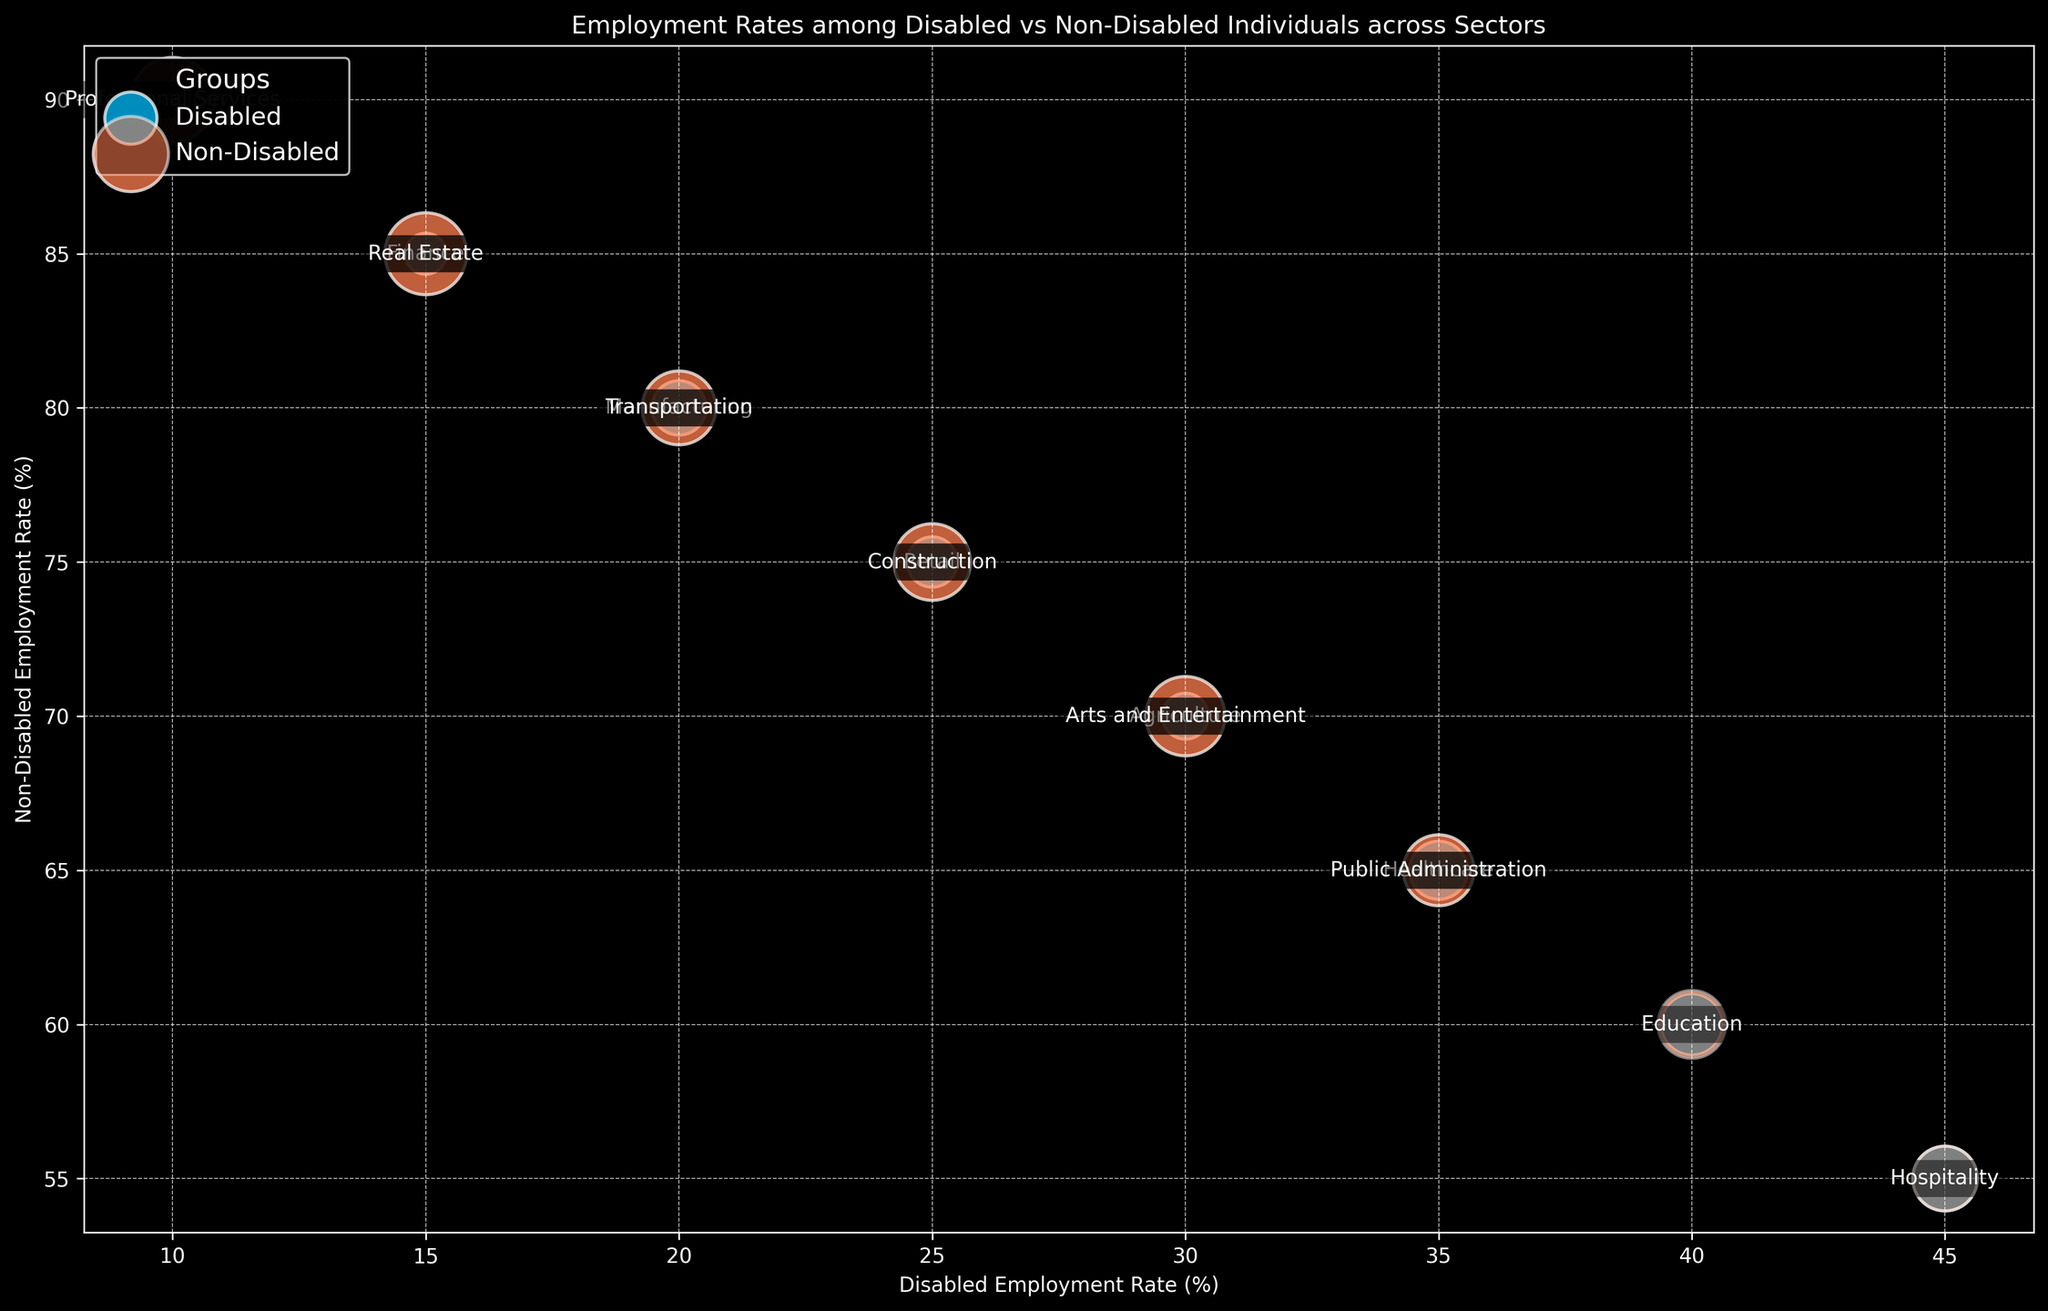Which sector has the highest employment rate for disabled individuals? Review the bubble chart and look for the bubble on the X-axis with the highest value. In this case, the highest disabled employment rate is 45% in the Hospitality sector.
Answer: Hospitality Which sector has the largest difference in employment rates between disabled and non-disabled individuals? Calculate the absolute differences between the disabled and non-disabled employment rates for each sector and find the maximum value. The largest difference is in Technology, with a difference of 80% (90% - 10%).
Answer: Technology Are there sectors where the disabled employment rate is higher than the non-disabled employment rate? Review the bubble chart for any sector where the bubble for disabled employment rate is higher on the X-axis than the corresponding non-disabled employment rate bubble on the Y-axis. In this chart, there are no such sectors.
Answer: No In which sector is the population of disabled individuals the largest, as indicated by the size of the bubbles? Look for the largest bubble among the bubbles representing the disabled population. The largest bubble corresponds to the Hospitality sector with a population of 100.
Answer: Hospitality Which sector has a similar employment rate for disabled and non-disabled individuals with the smallest difference? Calculate the difference in employment rates for each sector and identify the smallest value. The smallest difference is in the Hospitality sector, where the difference is 10% (55% - 45%).
Answer: Hospitality What color represents the non-disabled group's bubbles? Refer to the visual attributes of the bubbles and identify the color used for the non-disabled group. In this case, it is coral.
Answer: Coral 